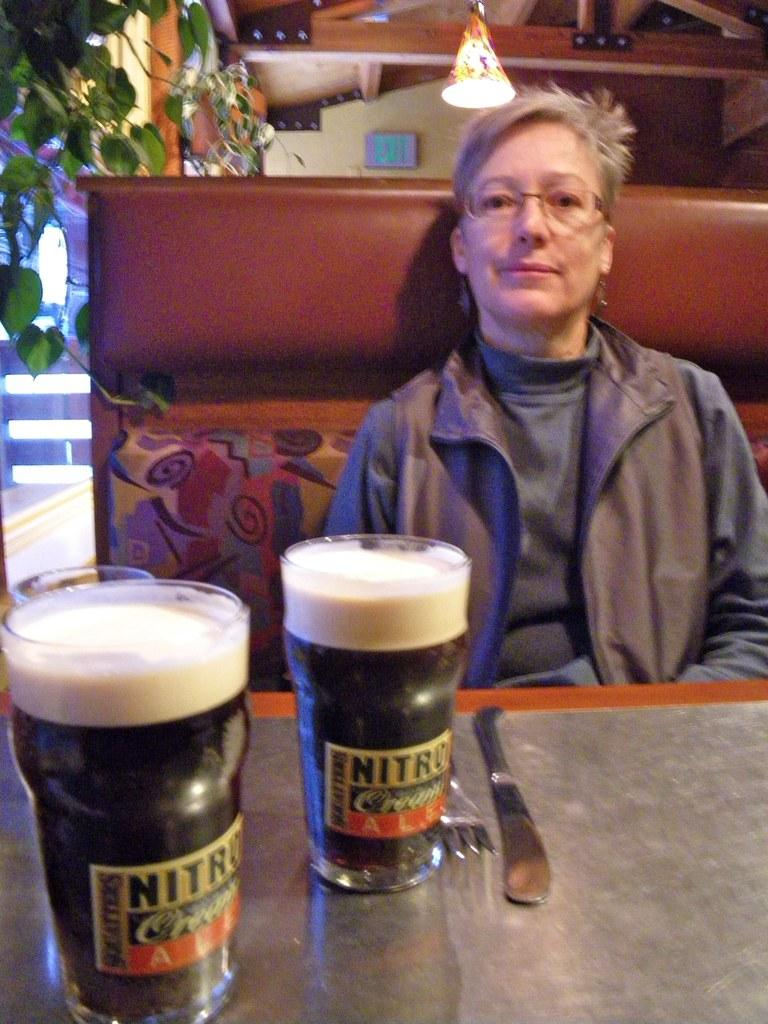Provide a one-sentence caption for the provided image. A person sitting in front of two points of dark beer with the words nitro on the glasses. 